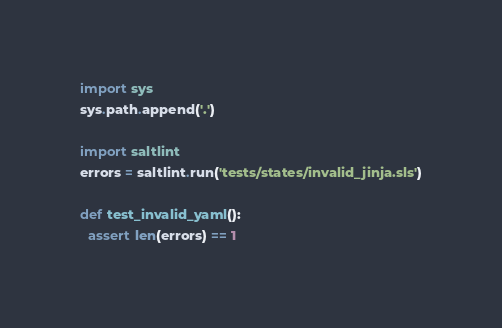Convert code to text. <code><loc_0><loc_0><loc_500><loc_500><_Python_>
import sys
sys.path.append('.')

import saltlint
errors = saltlint.run('tests/states/invalid_jinja.sls')

def test_invalid_yaml():
  assert len(errors) == 1
</code> 